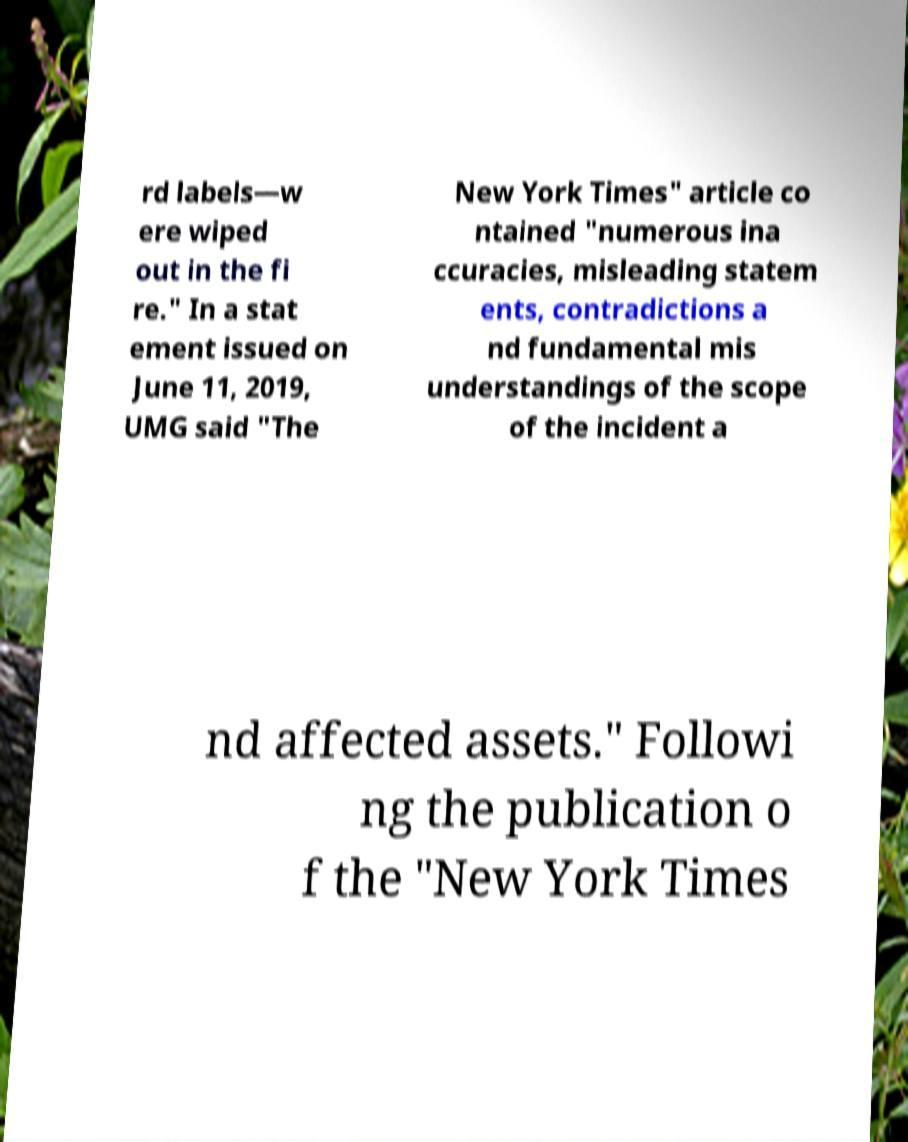For documentation purposes, I need the text within this image transcribed. Could you provide that? rd labels—w ere wiped out in the fi re." In a stat ement issued on June 11, 2019, UMG said "The New York Times" article co ntained "numerous ina ccuracies, misleading statem ents, contradictions a nd fundamental mis understandings of the scope of the incident a nd affected assets." Followi ng the publication o f the "New York Times 